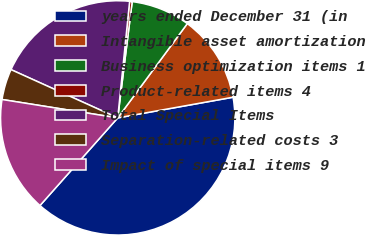Convert chart. <chart><loc_0><loc_0><loc_500><loc_500><pie_chart><fcel>years ended December 31 (in<fcel>Intangible asset amortization<fcel>Business optimization items 1<fcel>Product-related items 4<fcel>Total Special Items<fcel>Separation-related costs 3<fcel>Impact of special items 9<nl><fcel>39.37%<fcel>12.06%<fcel>8.15%<fcel>0.35%<fcel>19.86%<fcel>4.25%<fcel>15.96%<nl></chart> 